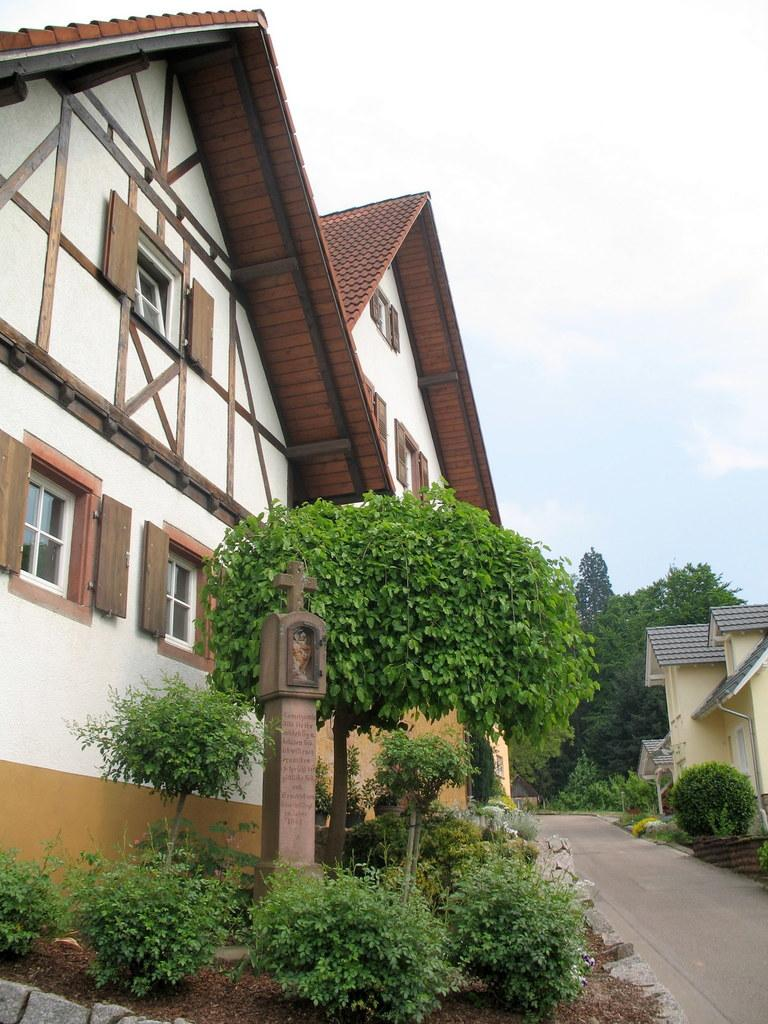What type of living organisms can be seen in the image? Plants can be seen in the image. What religious symbol is present on a pillar in the image? There is a cross symbol on a pillar in the image. What type of structures are visible in the image? Houses are visible in the image. What can be seen in the background of the image? Trees and the sky are visible in the background of the image. What type of tin is being used to feed the zebra in the image? There is no tin or zebra present in the image. How many carts are visible in the image? There are no carts visible in the image. 